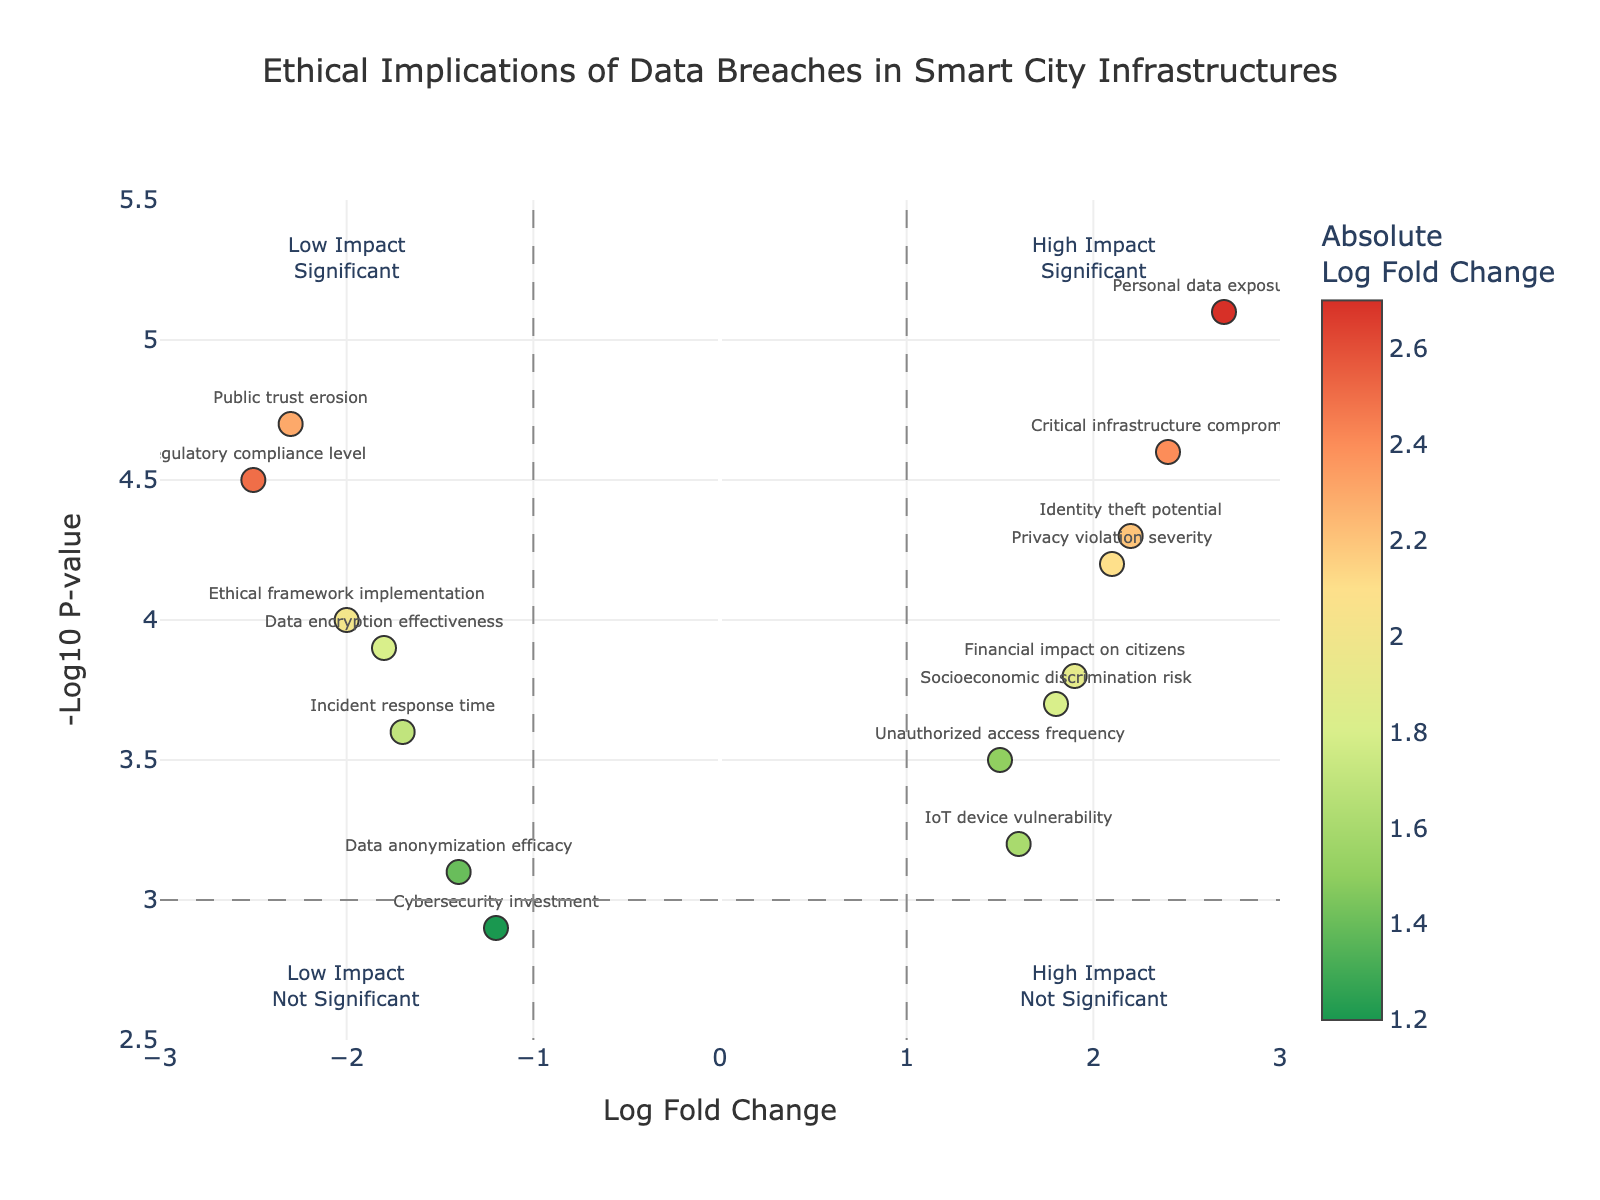What is the title of the plot? The title of the plot is located at the top center of the figure. It reads "Ethical Implications of Data Breaches in Smart City Infrastructures".
Answer: Ethical Implications of Data Breaches in Smart City Infrastructures How many factors are plotted in the figure? By counting the labeled data points, we see there are 15 different factors plotted in the figure.
Answer: 15 Which factor has the highest Log Fold Change? By locating the data point furthest to the right on the x-axis, "Personal data exposure risk" has the highest Log Fold Change at 2.7.
Answer: Personal data exposure risk Which factor has the lowest Log Fold Change? By locating the data point furthest to the left on the x-axis, "Regulatory compliance level" has the lowest Log Fold Change at -2.5.
Answer: Regulatory compliance level Which factor has the highest -Log10 P-value? By locating the data point highest on the y-axis, "Personal data exposure risk" has the highest -Log10 P-value at 5.1.
Answer: Personal data exposure risk What factor represents high impact and significant implications? Both criteria should be met: (1) Log Fold Change significantly different from 0 (absolute value large) and (2) -Log10 P-value high. "Personal data exposure risk" (Log Fold Change 2.7 and -Log10 P-value 5.1) satisfies both conditions.
Answer: Personal data exposure risk What factor represents low impact but significant implications? Both criteria should be met: (1) Log Fold Change close to 0 (absolute value small) but on the negative side and (2) -Log10 P-value high. "Regulatory compliance level" (Log Fold Change -2.5 and -Log10 P-value 4.5) satisfies both conditions.
Answer: Regulatory compliance level Which factors lie in the quadrant representing high impact but not significant implications? Factors in this quadrant have high Log Fold Change (outside the ±1 thresholds) and low -Log10 P-value (less than 3). There are two such factors: "IoT device vulnerability" and "Unauthorized access frequency".
Answer: IoT device vulnerability and Unauthorized access frequency Among "Financial impact on citizens" and "Data encryption effectiveness", which has a higher -Log10 P-value? By comparing their -Log10 P-values, "Financial impact on citizens" has a -Log10 P-value of 3.8, whereas "Data encryption effectiveness" has a -Log10 P-value of 3.9. "Data encryption effectiveness" has a higher -Log10 P-value.
Answer: Data encryption effectiveness What is the Log Fold Change for "Public trust erosion"? By identifying the "Public trust erosion" label, we see its Log Fold Change is -2.3.
Answer: -2.3 